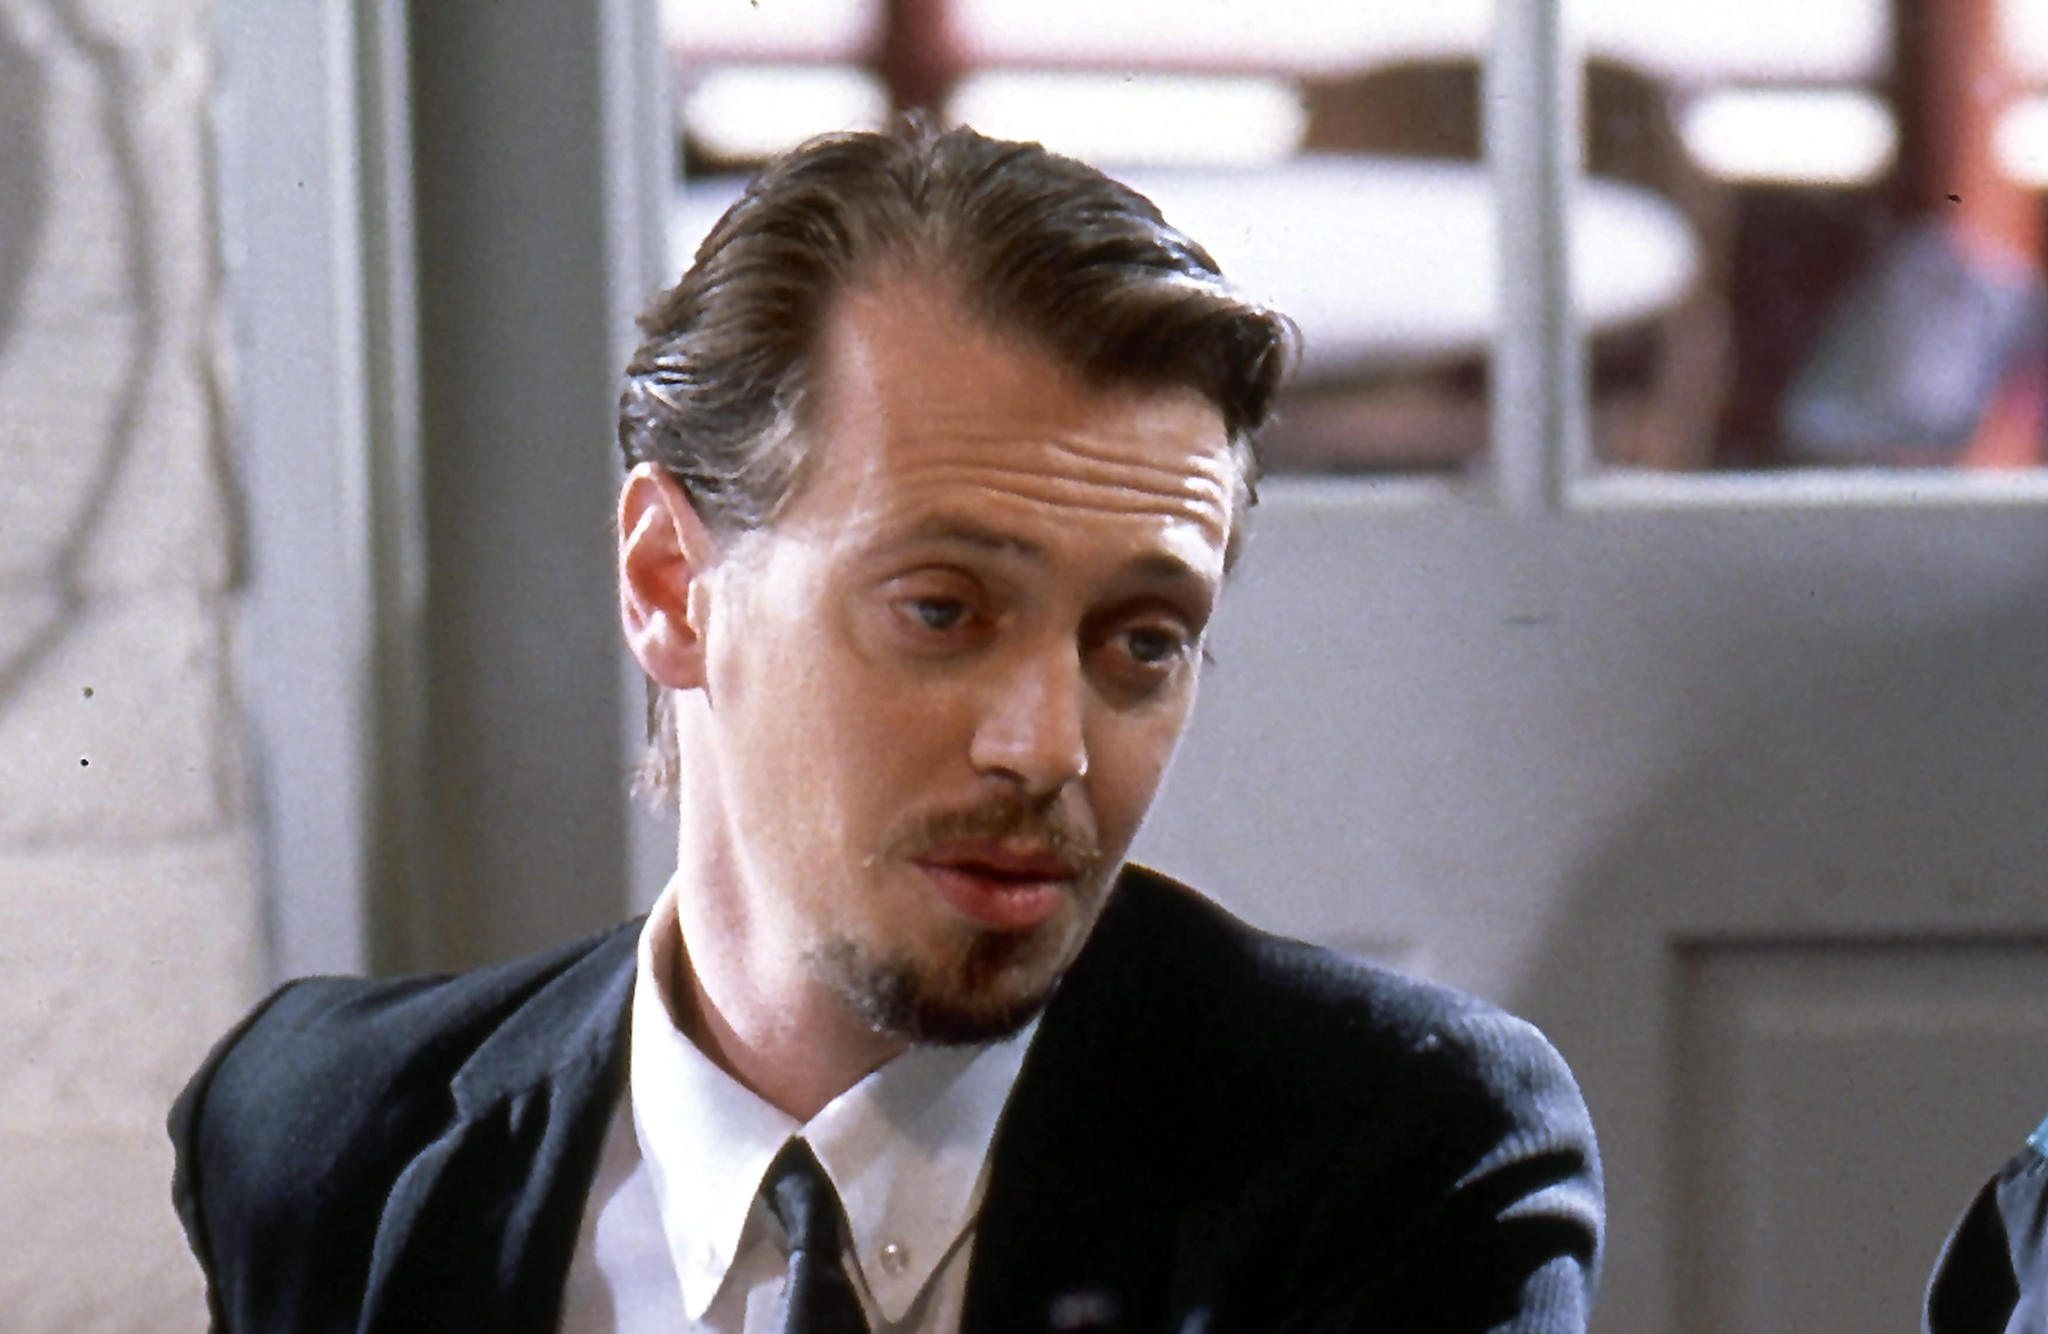Write a short and descriptive scenario of this character entering the café. Mr. Pink pushed open the café door, the soft jingle of the bell announcing his arrival. Dressed in a sleek black suit, he moved with a purposeful stride, his eyes scanning the room with a mix of caution and shrewdness. As he chose a table near the window, the dim light cast shadows that accentuated his sharp features and contemplative gaze. He sat down, his posture both relaxed and alert, ready to observe and calculate his next move in the ever-unfolding game of survival he was so expertly part of. 